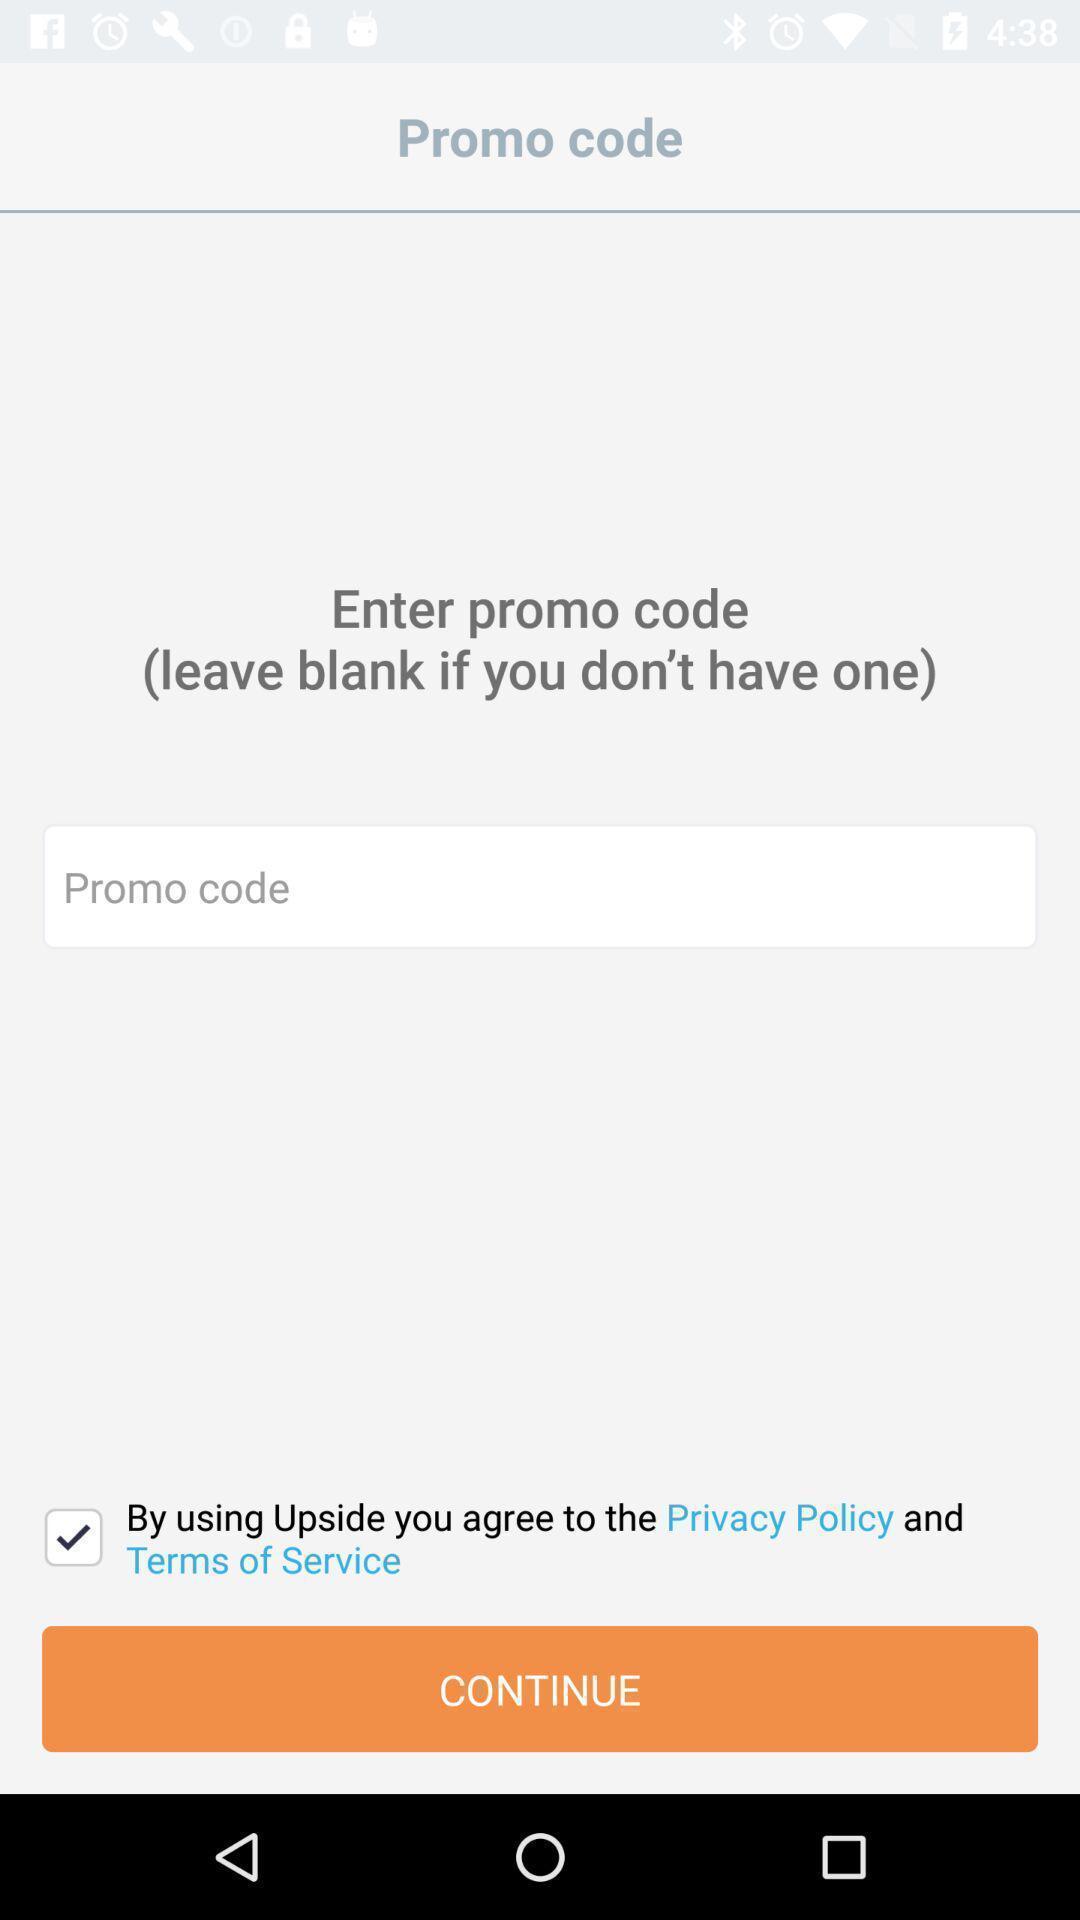Describe the visual elements of this screenshot. Screen shows promo code to continue with app. 